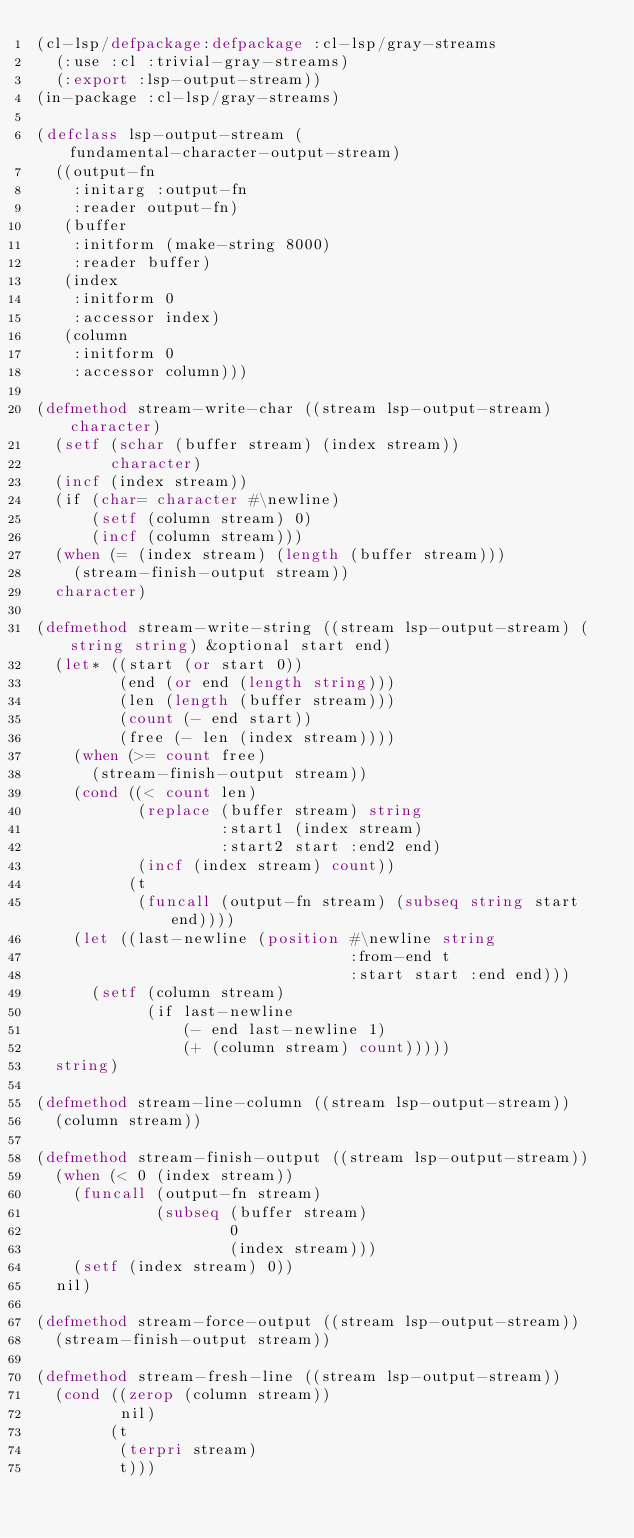<code> <loc_0><loc_0><loc_500><loc_500><_Lisp_>(cl-lsp/defpackage:defpackage :cl-lsp/gray-streams
  (:use :cl :trivial-gray-streams)
  (:export :lsp-output-stream))
(in-package :cl-lsp/gray-streams)

(defclass lsp-output-stream (fundamental-character-output-stream)
  ((output-fn
    :initarg :output-fn
    :reader output-fn)
   (buffer
    :initform (make-string 8000)
    :reader buffer)
   (index
    :initform 0
    :accessor index)
   (column
    :initform 0
    :accessor column)))

(defmethod stream-write-char ((stream lsp-output-stream) character)
  (setf (schar (buffer stream) (index stream))
        character)
  (incf (index stream))
  (if (char= character #\newline)
      (setf (column stream) 0)
      (incf (column stream)))
  (when (= (index stream) (length (buffer stream)))
    (stream-finish-output stream))
  character)

(defmethod stream-write-string ((stream lsp-output-stream) (string string) &optional start end)
  (let* ((start (or start 0))
         (end (or end (length string)))
         (len (length (buffer stream)))
         (count (- end start))
         (free (- len (index stream))))
    (when (>= count free)
      (stream-finish-output stream))
    (cond ((< count len)
           (replace (buffer stream) string
                    :start1 (index stream)
                    :start2 start :end2 end)
           (incf (index stream) count))
          (t
           (funcall (output-fn stream) (subseq string start end))))
    (let ((last-newline (position #\newline string
                                  :from-end t
                                  :start start :end end)))
      (setf (column stream)
            (if last-newline
                (- end last-newline 1)
                (+ (column stream) count)))))
  string)

(defmethod stream-line-column ((stream lsp-output-stream))
  (column stream))

(defmethod stream-finish-output ((stream lsp-output-stream))
  (when (< 0 (index stream))
    (funcall (output-fn stream)
             (subseq (buffer stream)
                     0
                     (index stream)))
    (setf (index stream) 0))
  nil)

(defmethod stream-force-output ((stream lsp-output-stream))
  (stream-finish-output stream))

(defmethod stream-fresh-line ((stream lsp-output-stream))
  (cond ((zerop (column stream))
         nil)
        (t
         (terpri stream)
         t)))
</code> 